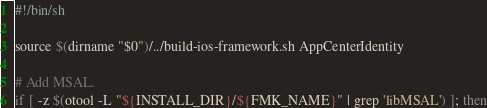Convert code to text. <code><loc_0><loc_0><loc_500><loc_500><_Bash_>#!/bin/sh

source $(dirname "$0")/../build-ios-framework.sh AppCenterIdentity

# Add MSAL.
if [ -z $(otool -L "${INSTALL_DIR}/${FMK_NAME}" | grep 'libMSAL') ]; then</code> 